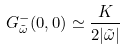Convert formula to latex. <formula><loc_0><loc_0><loc_500><loc_500>G ^ { - } _ { \tilde { \omega } } ( 0 , 0 ) \simeq \frac { K } { 2 | \tilde { \omega } | }</formula> 